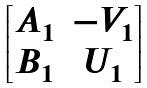<formula> <loc_0><loc_0><loc_500><loc_500>\begin{bmatrix} A _ { 1 } & - V _ { 1 } \\ B _ { 1 } & U _ { 1 } \end{bmatrix}</formula> 